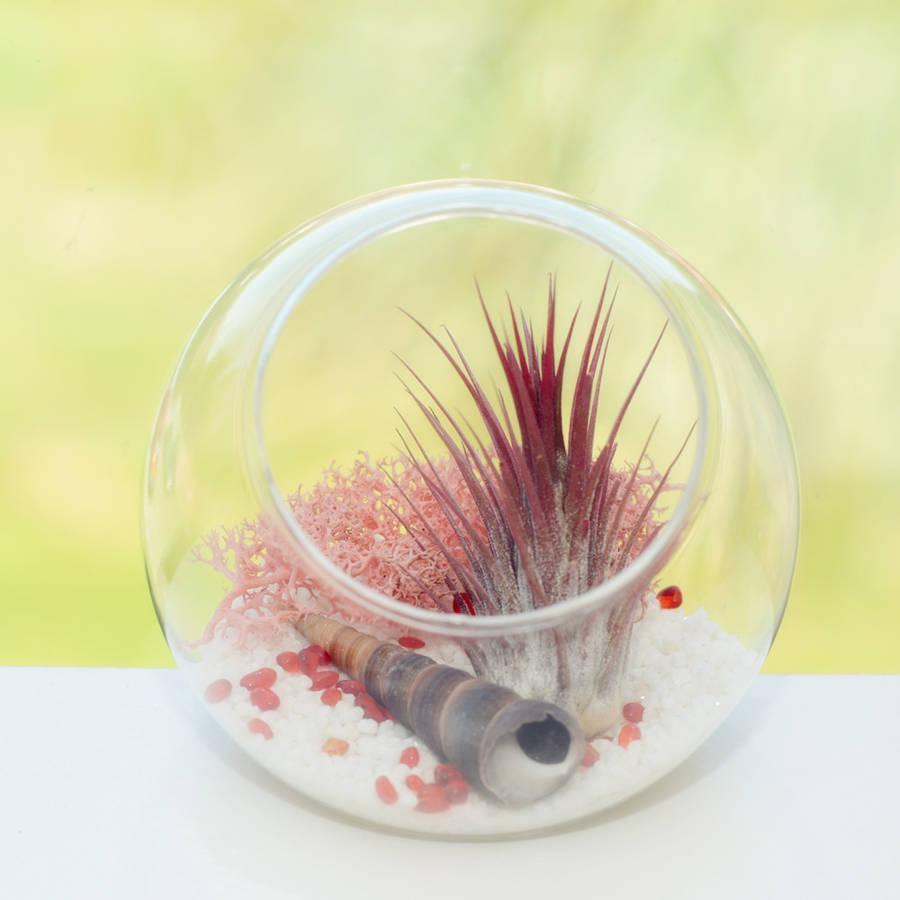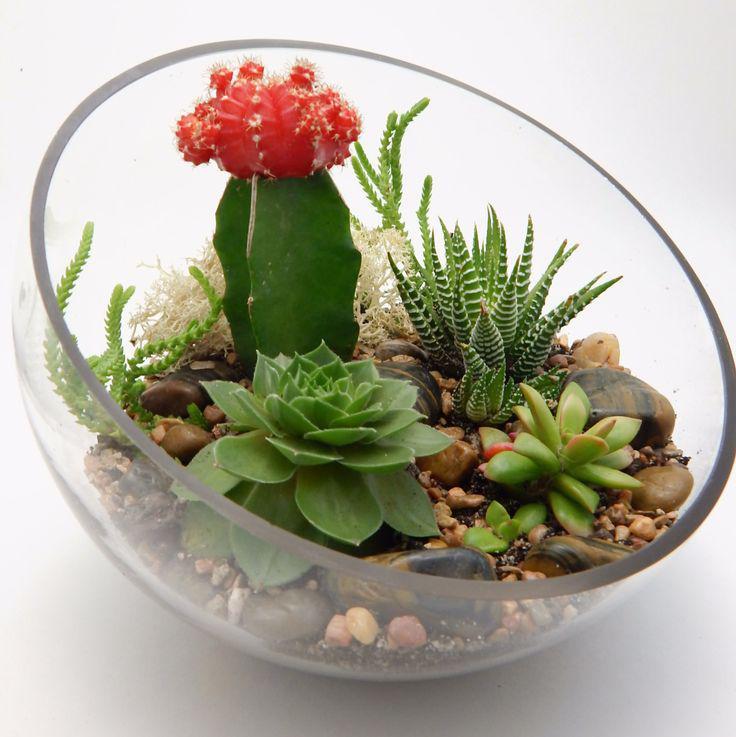The first image is the image on the left, the second image is the image on the right. For the images displayed, is the sentence "There are more containers holding plants in the image on the left." factually correct? Answer yes or no. No. The first image is the image on the left, the second image is the image on the right. Assess this claim about the two images: "There are at least two square glass holders with small green shrubbery and rock.". Correct or not? Answer yes or no. No. 